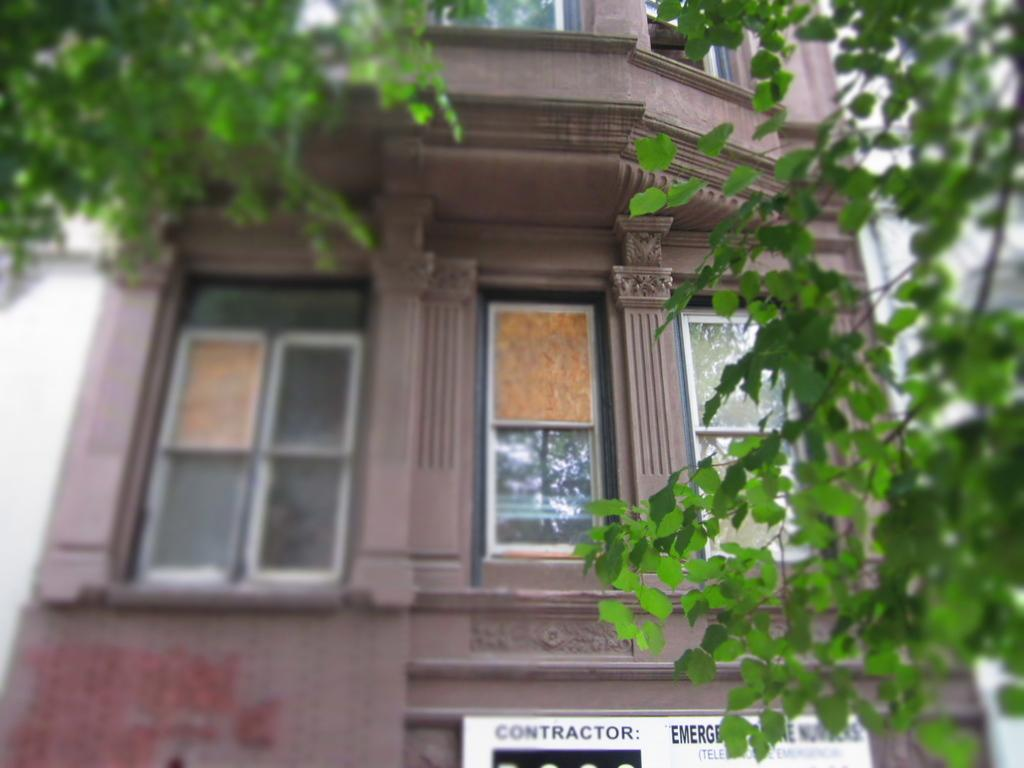What structure is the main subject of the image? There is a building in the image. Is there anything attached to the building? Yes, there is a board attached to the building. What can be seen on the board? There is text on the board. What type of vegetation is visible in the image? There are branches with leaves in the front side of the image. What type of flowers are growing near the building in the image? There are no flowers visible in the image; only branches with leaves are present. 